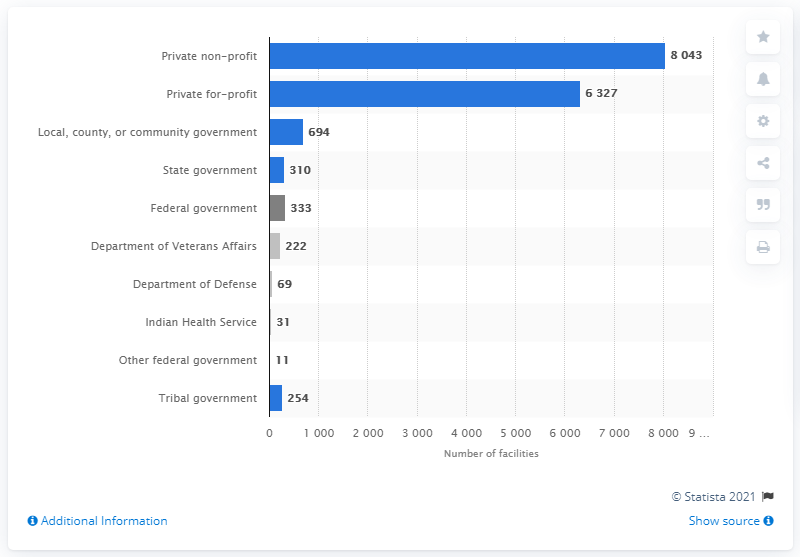Point out several critical features in this image. In 2019, there were 694 local, county, or community-run substance abuse treatment facilities in the United States. 